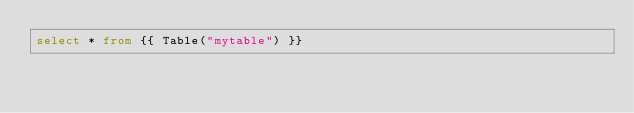Convert code to text. <code><loc_0><loc_0><loc_500><loc_500><_SQL_>select * from {{ Table("mytable") }}
</code> 